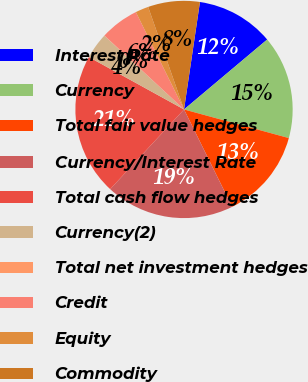<chart> <loc_0><loc_0><loc_500><loc_500><pie_chart><fcel>Interest Rate<fcel>Currency<fcel>Total fair value hedges<fcel>Currency/Interest Rate<fcel>Total cash flow hedges<fcel>Currency(2)<fcel>Total net investment hedges<fcel>Credit<fcel>Equity<fcel>Commodity<nl><fcel>11.53%<fcel>15.37%<fcel>13.45%<fcel>19.2%<fcel>21.12%<fcel>3.87%<fcel>0.03%<fcel>5.78%<fcel>1.95%<fcel>7.7%<nl></chart> 